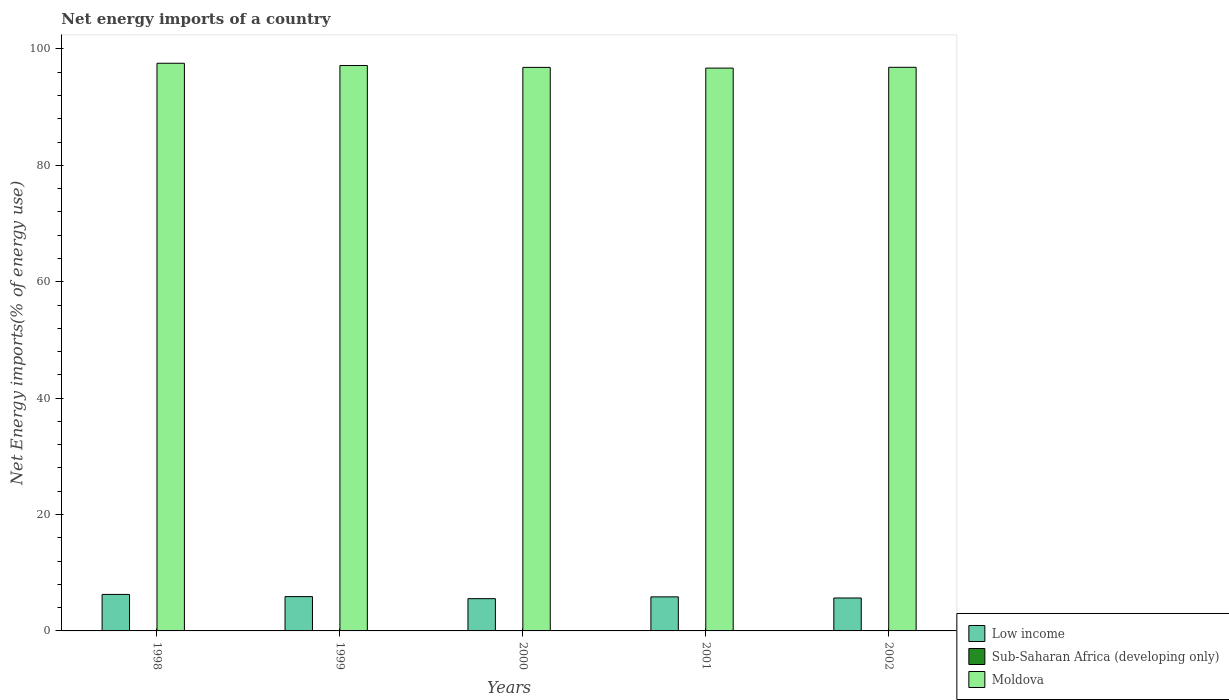Are the number of bars per tick equal to the number of legend labels?
Provide a short and direct response. No. Are the number of bars on each tick of the X-axis equal?
Ensure brevity in your answer.  Yes. In how many cases, is the number of bars for a given year not equal to the number of legend labels?
Offer a very short reply. 5. What is the net energy imports in Low income in 1998?
Give a very brief answer. 6.27. Across all years, what is the maximum net energy imports in Low income?
Give a very brief answer. 6.27. Across all years, what is the minimum net energy imports in Low income?
Offer a very short reply. 5.54. What is the total net energy imports in Moldova in the graph?
Offer a very short reply. 485.1. What is the difference between the net energy imports in Low income in 1999 and that in 2001?
Offer a very short reply. 0.04. What is the difference between the net energy imports in Low income in 1998 and the net energy imports in Sub-Saharan Africa (developing only) in 2002?
Your answer should be very brief. 6.27. What is the average net energy imports in Low income per year?
Your response must be concise. 5.84. In the year 1999, what is the difference between the net energy imports in Moldova and net energy imports in Low income?
Give a very brief answer. 91.27. In how many years, is the net energy imports in Low income greater than 92 %?
Your answer should be compact. 0. What is the ratio of the net energy imports in Moldova in 1998 to that in 1999?
Give a very brief answer. 1. What is the difference between the highest and the second highest net energy imports in Moldova?
Ensure brevity in your answer.  0.38. What is the difference between the highest and the lowest net energy imports in Low income?
Offer a terse response. 0.73. Is it the case that in every year, the sum of the net energy imports in Sub-Saharan Africa (developing only) and net energy imports in Low income is greater than the net energy imports in Moldova?
Offer a terse response. No. How many bars are there?
Make the answer very short. 10. How many years are there in the graph?
Offer a very short reply. 5. What is the difference between two consecutive major ticks on the Y-axis?
Your answer should be very brief. 20. Does the graph contain any zero values?
Your answer should be very brief. Yes. Where does the legend appear in the graph?
Your answer should be compact. Bottom right. How many legend labels are there?
Provide a short and direct response. 3. What is the title of the graph?
Provide a succinct answer. Net energy imports of a country. What is the label or title of the X-axis?
Make the answer very short. Years. What is the label or title of the Y-axis?
Provide a short and direct response. Net Energy imports(% of energy use). What is the Net Energy imports(% of energy use) in Low income in 1998?
Make the answer very short. 6.27. What is the Net Energy imports(% of energy use) in Moldova in 1998?
Make the answer very short. 97.54. What is the Net Energy imports(% of energy use) of Low income in 1999?
Offer a very short reply. 5.89. What is the Net Energy imports(% of energy use) of Moldova in 1999?
Ensure brevity in your answer.  97.16. What is the Net Energy imports(% of energy use) of Low income in 2000?
Ensure brevity in your answer.  5.54. What is the Net Energy imports(% of energy use) in Moldova in 2000?
Your response must be concise. 96.83. What is the Net Energy imports(% of energy use) of Low income in 2001?
Provide a short and direct response. 5.85. What is the Net Energy imports(% of energy use) of Moldova in 2001?
Make the answer very short. 96.71. What is the Net Energy imports(% of energy use) of Low income in 2002?
Ensure brevity in your answer.  5.66. What is the Net Energy imports(% of energy use) in Sub-Saharan Africa (developing only) in 2002?
Keep it short and to the point. 0. What is the Net Energy imports(% of energy use) of Moldova in 2002?
Offer a very short reply. 96.85. Across all years, what is the maximum Net Energy imports(% of energy use) in Low income?
Provide a succinct answer. 6.27. Across all years, what is the maximum Net Energy imports(% of energy use) in Moldova?
Offer a terse response. 97.54. Across all years, what is the minimum Net Energy imports(% of energy use) of Low income?
Your answer should be compact. 5.54. Across all years, what is the minimum Net Energy imports(% of energy use) in Moldova?
Offer a terse response. 96.71. What is the total Net Energy imports(% of energy use) of Low income in the graph?
Offer a terse response. 29.22. What is the total Net Energy imports(% of energy use) of Sub-Saharan Africa (developing only) in the graph?
Your answer should be very brief. 0. What is the total Net Energy imports(% of energy use) in Moldova in the graph?
Your answer should be very brief. 485.1. What is the difference between the Net Energy imports(% of energy use) in Low income in 1998 and that in 1999?
Your answer should be very brief. 0.38. What is the difference between the Net Energy imports(% of energy use) of Moldova in 1998 and that in 1999?
Your answer should be very brief. 0.38. What is the difference between the Net Energy imports(% of energy use) of Low income in 1998 and that in 2000?
Ensure brevity in your answer.  0.73. What is the difference between the Net Energy imports(% of energy use) in Moldova in 1998 and that in 2000?
Provide a short and direct response. 0.71. What is the difference between the Net Energy imports(% of energy use) in Low income in 1998 and that in 2001?
Ensure brevity in your answer.  0.42. What is the difference between the Net Energy imports(% of energy use) of Moldova in 1998 and that in 2001?
Provide a succinct answer. 0.83. What is the difference between the Net Energy imports(% of energy use) of Low income in 1998 and that in 2002?
Your response must be concise. 0.61. What is the difference between the Net Energy imports(% of energy use) of Moldova in 1998 and that in 2002?
Ensure brevity in your answer.  0.7. What is the difference between the Net Energy imports(% of energy use) of Low income in 1999 and that in 2000?
Offer a terse response. 0.35. What is the difference between the Net Energy imports(% of energy use) of Moldova in 1999 and that in 2000?
Keep it short and to the point. 0.33. What is the difference between the Net Energy imports(% of energy use) of Low income in 1999 and that in 2001?
Provide a short and direct response. 0.04. What is the difference between the Net Energy imports(% of energy use) of Moldova in 1999 and that in 2001?
Your answer should be very brief. 0.45. What is the difference between the Net Energy imports(% of energy use) in Low income in 1999 and that in 2002?
Offer a very short reply. 0.24. What is the difference between the Net Energy imports(% of energy use) of Moldova in 1999 and that in 2002?
Your response must be concise. 0.31. What is the difference between the Net Energy imports(% of energy use) of Low income in 2000 and that in 2001?
Keep it short and to the point. -0.31. What is the difference between the Net Energy imports(% of energy use) of Moldova in 2000 and that in 2001?
Make the answer very short. 0.12. What is the difference between the Net Energy imports(% of energy use) in Low income in 2000 and that in 2002?
Offer a terse response. -0.12. What is the difference between the Net Energy imports(% of energy use) of Moldova in 2000 and that in 2002?
Your answer should be compact. -0.01. What is the difference between the Net Energy imports(% of energy use) of Low income in 2001 and that in 2002?
Your response must be concise. 0.19. What is the difference between the Net Energy imports(% of energy use) in Moldova in 2001 and that in 2002?
Give a very brief answer. -0.14. What is the difference between the Net Energy imports(% of energy use) in Low income in 1998 and the Net Energy imports(% of energy use) in Moldova in 1999?
Your answer should be very brief. -90.89. What is the difference between the Net Energy imports(% of energy use) of Low income in 1998 and the Net Energy imports(% of energy use) of Moldova in 2000?
Provide a short and direct response. -90.56. What is the difference between the Net Energy imports(% of energy use) in Low income in 1998 and the Net Energy imports(% of energy use) in Moldova in 2001?
Offer a terse response. -90.44. What is the difference between the Net Energy imports(% of energy use) in Low income in 1998 and the Net Energy imports(% of energy use) in Moldova in 2002?
Provide a succinct answer. -90.58. What is the difference between the Net Energy imports(% of energy use) in Low income in 1999 and the Net Energy imports(% of energy use) in Moldova in 2000?
Your answer should be compact. -90.94. What is the difference between the Net Energy imports(% of energy use) of Low income in 1999 and the Net Energy imports(% of energy use) of Moldova in 2001?
Give a very brief answer. -90.82. What is the difference between the Net Energy imports(% of energy use) of Low income in 1999 and the Net Energy imports(% of energy use) of Moldova in 2002?
Your answer should be compact. -90.95. What is the difference between the Net Energy imports(% of energy use) in Low income in 2000 and the Net Energy imports(% of energy use) in Moldova in 2001?
Your answer should be very brief. -91.17. What is the difference between the Net Energy imports(% of energy use) in Low income in 2000 and the Net Energy imports(% of energy use) in Moldova in 2002?
Ensure brevity in your answer.  -91.31. What is the difference between the Net Energy imports(% of energy use) of Low income in 2001 and the Net Energy imports(% of energy use) of Moldova in 2002?
Your answer should be very brief. -91. What is the average Net Energy imports(% of energy use) of Low income per year?
Your answer should be compact. 5.84. What is the average Net Energy imports(% of energy use) of Moldova per year?
Give a very brief answer. 97.02. In the year 1998, what is the difference between the Net Energy imports(% of energy use) of Low income and Net Energy imports(% of energy use) of Moldova?
Your answer should be very brief. -91.27. In the year 1999, what is the difference between the Net Energy imports(% of energy use) of Low income and Net Energy imports(% of energy use) of Moldova?
Give a very brief answer. -91.27. In the year 2000, what is the difference between the Net Energy imports(% of energy use) in Low income and Net Energy imports(% of energy use) in Moldova?
Your answer should be very brief. -91.29. In the year 2001, what is the difference between the Net Energy imports(% of energy use) in Low income and Net Energy imports(% of energy use) in Moldova?
Give a very brief answer. -90.86. In the year 2002, what is the difference between the Net Energy imports(% of energy use) in Low income and Net Energy imports(% of energy use) in Moldova?
Provide a short and direct response. -91.19. What is the ratio of the Net Energy imports(% of energy use) in Low income in 1998 to that in 1999?
Make the answer very short. 1.06. What is the ratio of the Net Energy imports(% of energy use) of Low income in 1998 to that in 2000?
Ensure brevity in your answer.  1.13. What is the ratio of the Net Energy imports(% of energy use) in Moldova in 1998 to that in 2000?
Offer a terse response. 1.01. What is the ratio of the Net Energy imports(% of energy use) in Low income in 1998 to that in 2001?
Your response must be concise. 1.07. What is the ratio of the Net Energy imports(% of energy use) of Moldova in 1998 to that in 2001?
Your answer should be compact. 1.01. What is the ratio of the Net Energy imports(% of energy use) in Low income in 1998 to that in 2002?
Offer a terse response. 1.11. What is the ratio of the Net Energy imports(% of energy use) of Moldova in 1998 to that in 2002?
Ensure brevity in your answer.  1.01. What is the ratio of the Net Energy imports(% of energy use) of Low income in 1999 to that in 2000?
Offer a terse response. 1.06. What is the ratio of the Net Energy imports(% of energy use) of Moldova in 1999 to that in 2000?
Offer a terse response. 1. What is the ratio of the Net Energy imports(% of energy use) in Low income in 1999 to that in 2001?
Ensure brevity in your answer.  1.01. What is the ratio of the Net Energy imports(% of energy use) in Moldova in 1999 to that in 2001?
Your answer should be very brief. 1. What is the ratio of the Net Energy imports(% of energy use) of Low income in 1999 to that in 2002?
Ensure brevity in your answer.  1.04. What is the ratio of the Net Energy imports(% of energy use) in Moldova in 1999 to that in 2002?
Provide a succinct answer. 1. What is the ratio of the Net Energy imports(% of energy use) of Low income in 2000 to that in 2002?
Your response must be concise. 0.98. What is the ratio of the Net Energy imports(% of energy use) of Low income in 2001 to that in 2002?
Provide a short and direct response. 1.03. What is the difference between the highest and the second highest Net Energy imports(% of energy use) of Low income?
Keep it short and to the point. 0.38. What is the difference between the highest and the second highest Net Energy imports(% of energy use) in Moldova?
Keep it short and to the point. 0.38. What is the difference between the highest and the lowest Net Energy imports(% of energy use) in Low income?
Your answer should be very brief. 0.73. What is the difference between the highest and the lowest Net Energy imports(% of energy use) in Moldova?
Offer a terse response. 0.83. 